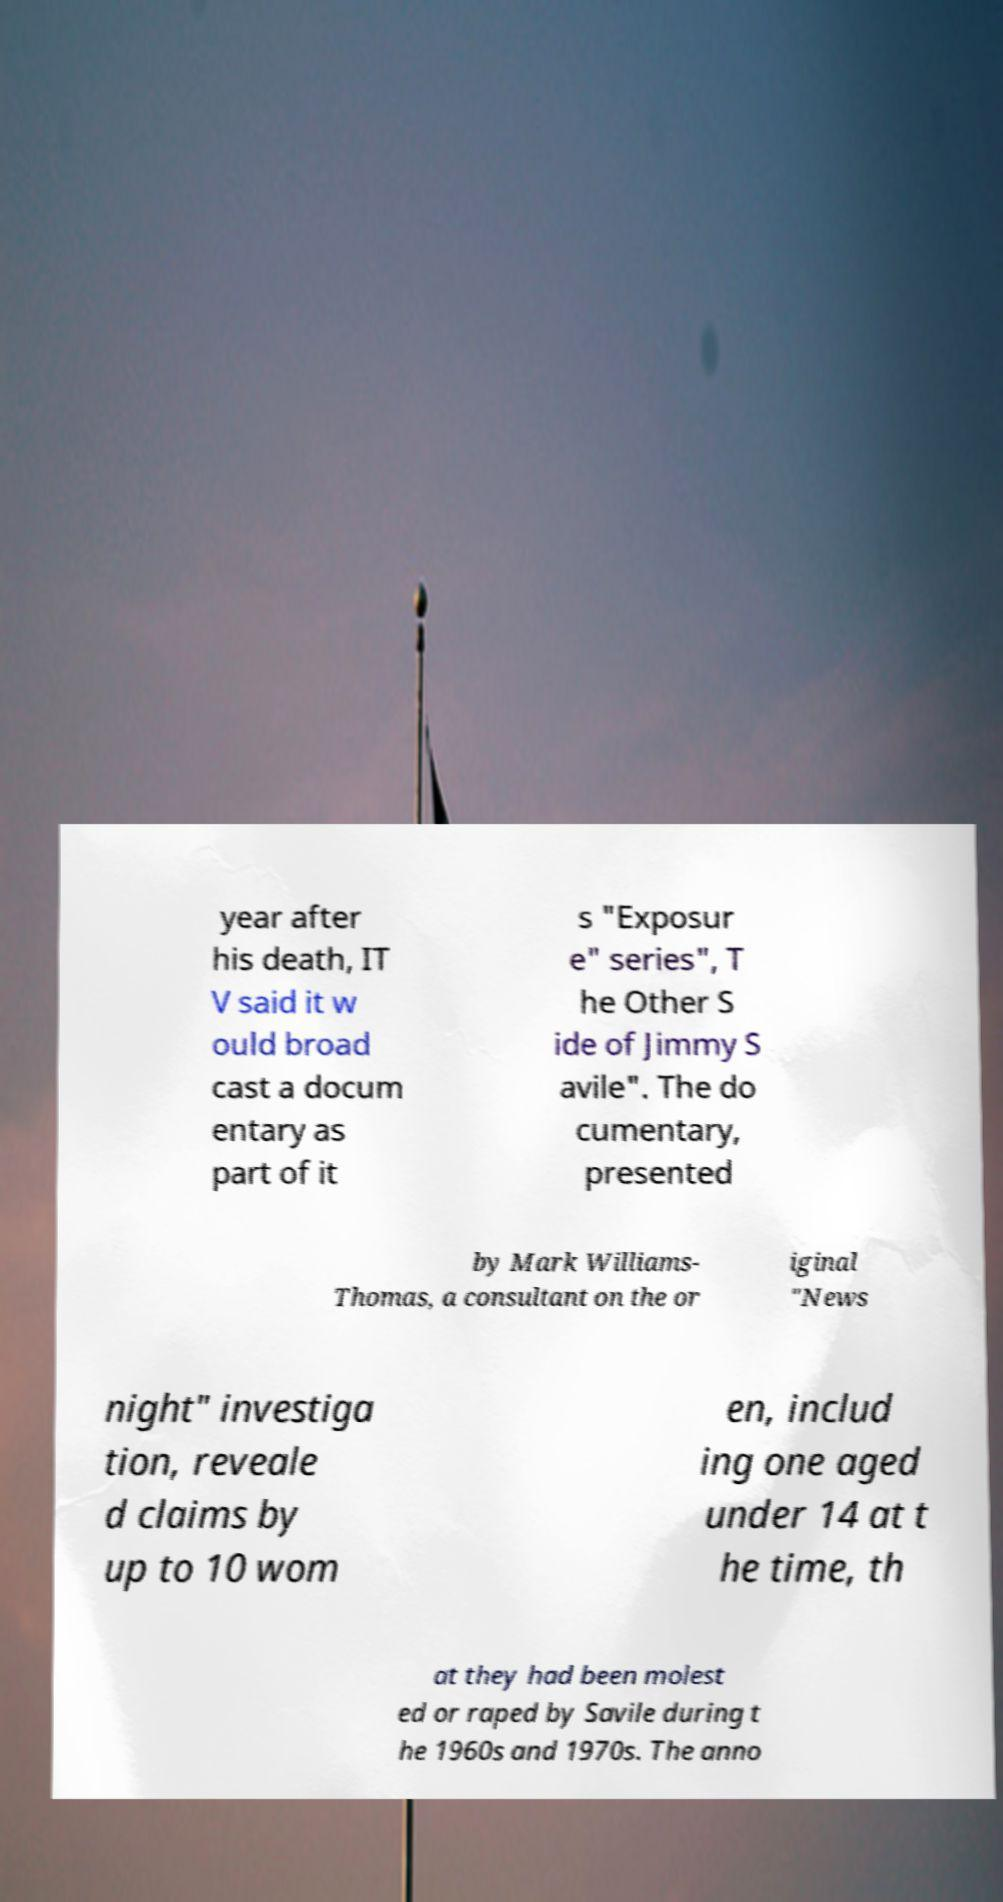Could you extract and type out the text from this image? year after his death, IT V said it w ould broad cast a docum entary as part of it s "Exposur e" series", T he Other S ide of Jimmy S avile". The do cumentary, presented by Mark Williams- Thomas, a consultant on the or iginal "News night" investiga tion, reveale d claims by up to 10 wom en, includ ing one aged under 14 at t he time, th at they had been molest ed or raped by Savile during t he 1960s and 1970s. The anno 